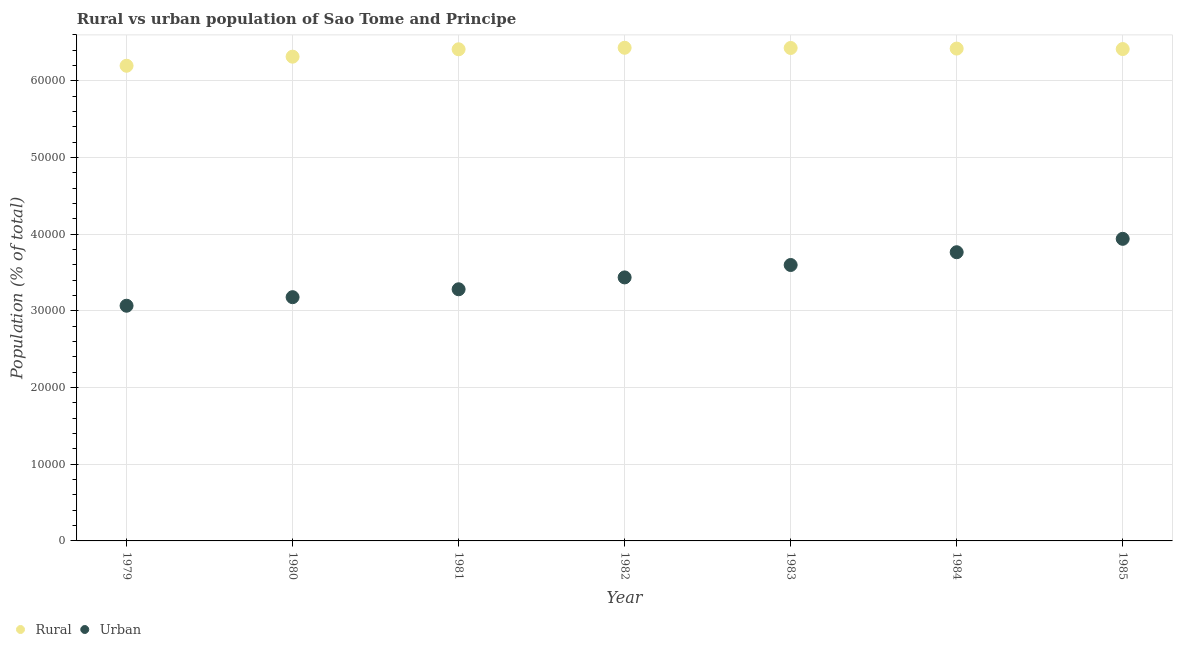Is the number of dotlines equal to the number of legend labels?
Ensure brevity in your answer.  Yes. What is the rural population density in 1984?
Ensure brevity in your answer.  6.42e+04. Across all years, what is the maximum rural population density?
Ensure brevity in your answer.  6.43e+04. Across all years, what is the minimum rural population density?
Keep it short and to the point. 6.20e+04. In which year was the urban population density maximum?
Offer a very short reply. 1985. In which year was the rural population density minimum?
Your answer should be compact. 1979. What is the total rural population density in the graph?
Your response must be concise. 4.46e+05. What is the difference between the rural population density in 1982 and that in 1985?
Keep it short and to the point. 167. What is the difference between the urban population density in 1982 and the rural population density in 1983?
Keep it short and to the point. -2.99e+04. What is the average rural population density per year?
Make the answer very short. 6.38e+04. In the year 1984, what is the difference between the urban population density and rural population density?
Keep it short and to the point. -2.66e+04. What is the ratio of the rural population density in 1982 to that in 1984?
Your answer should be very brief. 1. Is the difference between the urban population density in 1979 and 1985 greater than the difference between the rural population density in 1979 and 1985?
Provide a succinct answer. No. What is the difference between the highest and the second highest urban population density?
Offer a terse response. 1747. What is the difference between the highest and the lowest rural population density?
Give a very brief answer. 2346. Is the sum of the rural population density in 1981 and 1983 greater than the maximum urban population density across all years?
Your answer should be compact. Yes. How many dotlines are there?
Your answer should be compact. 2. What is the difference between two consecutive major ticks on the Y-axis?
Provide a short and direct response. 10000. Are the values on the major ticks of Y-axis written in scientific E-notation?
Your answer should be very brief. No. Does the graph contain any zero values?
Keep it short and to the point. No. Does the graph contain grids?
Your response must be concise. Yes. Where does the legend appear in the graph?
Provide a succinct answer. Bottom left. How many legend labels are there?
Provide a short and direct response. 2. What is the title of the graph?
Provide a short and direct response. Rural vs urban population of Sao Tome and Principe. Does "Largest city" appear as one of the legend labels in the graph?
Ensure brevity in your answer.  No. What is the label or title of the X-axis?
Your answer should be very brief. Year. What is the label or title of the Y-axis?
Provide a short and direct response. Population (% of total). What is the Population (% of total) in Rural in 1979?
Your answer should be compact. 6.20e+04. What is the Population (% of total) of Urban in 1979?
Your answer should be very brief. 3.07e+04. What is the Population (% of total) in Rural in 1980?
Provide a short and direct response. 6.32e+04. What is the Population (% of total) of Urban in 1980?
Your answer should be very brief. 3.18e+04. What is the Population (% of total) in Rural in 1981?
Provide a short and direct response. 6.41e+04. What is the Population (% of total) in Urban in 1981?
Provide a short and direct response. 3.28e+04. What is the Population (% of total) of Rural in 1982?
Your answer should be very brief. 6.43e+04. What is the Population (% of total) of Urban in 1982?
Your answer should be compact. 3.44e+04. What is the Population (% of total) in Rural in 1983?
Offer a terse response. 6.43e+04. What is the Population (% of total) in Urban in 1983?
Offer a very short reply. 3.60e+04. What is the Population (% of total) in Rural in 1984?
Keep it short and to the point. 6.42e+04. What is the Population (% of total) in Urban in 1984?
Offer a terse response. 3.77e+04. What is the Population (% of total) of Rural in 1985?
Your answer should be compact. 6.42e+04. What is the Population (% of total) of Urban in 1985?
Your response must be concise. 3.94e+04. Across all years, what is the maximum Population (% of total) in Rural?
Provide a succinct answer. 6.43e+04. Across all years, what is the maximum Population (% of total) in Urban?
Offer a very short reply. 3.94e+04. Across all years, what is the minimum Population (% of total) in Rural?
Your answer should be very brief. 6.20e+04. Across all years, what is the minimum Population (% of total) in Urban?
Keep it short and to the point. 3.07e+04. What is the total Population (% of total) in Rural in the graph?
Your response must be concise. 4.46e+05. What is the total Population (% of total) of Urban in the graph?
Your answer should be very brief. 2.43e+05. What is the difference between the Population (% of total) in Rural in 1979 and that in 1980?
Provide a short and direct response. -1185. What is the difference between the Population (% of total) in Urban in 1979 and that in 1980?
Your response must be concise. -1116. What is the difference between the Population (% of total) in Rural in 1979 and that in 1981?
Make the answer very short. -2148. What is the difference between the Population (% of total) in Urban in 1979 and that in 1981?
Give a very brief answer. -2147. What is the difference between the Population (% of total) in Rural in 1979 and that in 1982?
Make the answer very short. -2346. What is the difference between the Population (% of total) of Urban in 1979 and that in 1982?
Your response must be concise. -3694. What is the difference between the Population (% of total) of Rural in 1979 and that in 1983?
Offer a very short reply. -2320. What is the difference between the Population (% of total) in Urban in 1979 and that in 1983?
Offer a terse response. -5313. What is the difference between the Population (% of total) in Rural in 1979 and that in 1984?
Provide a short and direct response. -2240. What is the difference between the Population (% of total) of Urban in 1979 and that in 1984?
Provide a succinct answer. -6979. What is the difference between the Population (% of total) in Rural in 1979 and that in 1985?
Offer a terse response. -2179. What is the difference between the Population (% of total) of Urban in 1979 and that in 1985?
Offer a very short reply. -8726. What is the difference between the Population (% of total) of Rural in 1980 and that in 1981?
Provide a short and direct response. -963. What is the difference between the Population (% of total) in Urban in 1980 and that in 1981?
Offer a very short reply. -1031. What is the difference between the Population (% of total) in Rural in 1980 and that in 1982?
Make the answer very short. -1161. What is the difference between the Population (% of total) of Urban in 1980 and that in 1982?
Ensure brevity in your answer.  -2578. What is the difference between the Population (% of total) of Rural in 1980 and that in 1983?
Keep it short and to the point. -1135. What is the difference between the Population (% of total) in Urban in 1980 and that in 1983?
Provide a succinct answer. -4197. What is the difference between the Population (% of total) of Rural in 1980 and that in 1984?
Ensure brevity in your answer.  -1055. What is the difference between the Population (% of total) in Urban in 1980 and that in 1984?
Give a very brief answer. -5863. What is the difference between the Population (% of total) of Rural in 1980 and that in 1985?
Keep it short and to the point. -994. What is the difference between the Population (% of total) of Urban in 1980 and that in 1985?
Provide a short and direct response. -7610. What is the difference between the Population (% of total) of Rural in 1981 and that in 1982?
Provide a succinct answer. -198. What is the difference between the Population (% of total) in Urban in 1981 and that in 1982?
Give a very brief answer. -1547. What is the difference between the Population (% of total) of Rural in 1981 and that in 1983?
Your answer should be compact. -172. What is the difference between the Population (% of total) in Urban in 1981 and that in 1983?
Your answer should be compact. -3166. What is the difference between the Population (% of total) in Rural in 1981 and that in 1984?
Offer a very short reply. -92. What is the difference between the Population (% of total) in Urban in 1981 and that in 1984?
Provide a short and direct response. -4832. What is the difference between the Population (% of total) in Rural in 1981 and that in 1985?
Offer a very short reply. -31. What is the difference between the Population (% of total) in Urban in 1981 and that in 1985?
Give a very brief answer. -6579. What is the difference between the Population (% of total) in Urban in 1982 and that in 1983?
Offer a terse response. -1619. What is the difference between the Population (% of total) in Rural in 1982 and that in 1984?
Your response must be concise. 106. What is the difference between the Population (% of total) in Urban in 1982 and that in 1984?
Your answer should be compact. -3285. What is the difference between the Population (% of total) in Rural in 1982 and that in 1985?
Provide a short and direct response. 167. What is the difference between the Population (% of total) in Urban in 1982 and that in 1985?
Ensure brevity in your answer.  -5032. What is the difference between the Population (% of total) in Rural in 1983 and that in 1984?
Your answer should be compact. 80. What is the difference between the Population (% of total) in Urban in 1983 and that in 1984?
Provide a succinct answer. -1666. What is the difference between the Population (% of total) of Rural in 1983 and that in 1985?
Offer a very short reply. 141. What is the difference between the Population (% of total) in Urban in 1983 and that in 1985?
Provide a short and direct response. -3413. What is the difference between the Population (% of total) in Rural in 1984 and that in 1985?
Make the answer very short. 61. What is the difference between the Population (% of total) in Urban in 1984 and that in 1985?
Ensure brevity in your answer.  -1747. What is the difference between the Population (% of total) of Rural in 1979 and the Population (% of total) of Urban in 1980?
Offer a terse response. 3.02e+04. What is the difference between the Population (% of total) in Rural in 1979 and the Population (% of total) in Urban in 1981?
Provide a succinct answer. 2.92e+04. What is the difference between the Population (% of total) in Rural in 1979 and the Population (% of total) in Urban in 1982?
Provide a succinct answer. 2.76e+04. What is the difference between the Population (% of total) of Rural in 1979 and the Population (% of total) of Urban in 1983?
Make the answer very short. 2.60e+04. What is the difference between the Population (% of total) in Rural in 1979 and the Population (% of total) in Urban in 1984?
Give a very brief answer. 2.43e+04. What is the difference between the Population (% of total) of Rural in 1979 and the Population (% of total) of Urban in 1985?
Provide a short and direct response. 2.26e+04. What is the difference between the Population (% of total) in Rural in 1980 and the Population (% of total) in Urban in 1981?
Provide a succinct answer. 3.03e+04. What is the difference between the Population (% of total) of Rural in 1980 and the Population (% of total) of Urban in 1982?
Ensure brevity in your answer.  2.88e+04. What is the difference between the Population (% of total) in Rural in 1980 and the Population (% of total) in Urban in 1983?
Offer a very short reply. 2.72e+04. What is the difference between the Population (% of total) in Rural in 1980 and the Population (% of total) in Urban in 1984?
Your answer should be compact. 2.55e+04. What is the difference between the Population (% of total) of Rural in 1980 and the Population (% of total) of Urban in 1985?
Offer a terse response. 2.38e+04. What is the difference between the Population (% of total) in Rural in 1981 and the Population (% of total) in Urban in 1982?
Give a very brief answer. 2.98e+04. What is the difference between the Population (% of total) in Rural in 1981 and the Population (% of total) in Urban in 1983?
Give a very brief answer. 2.81e+04. What is the difference between the Population (% of total) of Rural in 1981 and the Population (% of total) of Urban in 1984?
Your answer should be compact. 2.65e+04. What is the difference between the Population (% of total) of Rural in 1981 and the Population (% of total) of Urban in 1985?
Make the answer very short. 2.47e+04. What is the difference between the Population (% of total) in Rural in 1982 and the Population (% of total) in Urban in 1983?
Offer a very short reply. 2.83e+04. What is the difference between the Population (% of total) in Rural in 1982 and the Population (% of total) in Urban in 1984?
Offer a very short reply. 2.67e+04. What is the difference between the Population (% of total) of Rural in 1982 and the Population (% of total) of Urban in 1985?
Your response must be concise. 2.49e+04. What is the difference between the Population (% of total) in Rural in 1983 and the Population (% of total) in Urban in 1984?
Ensure brevity in your answer.  2.66e+04. What is the difference between the Population (% of total) in Rural in 1983 and the Population (% of total) in Urban in 1985?
Your response must be concise. 2.49e+04. What is the difference between the Population (% of total) of Rural in 1984 and the Population (% of total) of Urban in 1985?
Ensure brevity in your answer.  2.48e+04. What is the average Population (% of total) of Rural per year?
Your answer should be compact. 6.38e+04. What is the average Population (% of total) of Urban per year?
Your answer should be compact. 3.47e+04. In the year 1979, what is the difference between the Population (% of total) in Rural and Population (% of total) in Urban?
Provide a short and direct response. 3.13e+04. In the year 1980, what is the difference between the Population (% of total) in Rural and Population (% of total) in Urban?
Your response must be concise. 3.14e+04. In the year 1981, what is the difference between the Population (% of total) of Rural and Population (% of total) of Urban?
Provide a succinct answer. 3.13e+04. In the year 1982, what is the difference between the Population (% of total) of Rural and Population (% of total) of Urban?
Provide a succinct answer. 3.00e+04. In the year 1983, what is the difference between the Population (% of total) of Rural and Population (% of total) of Urban?
Keep it short and to the point. 2.83e+04. In the year 1984, what is the difference between the Population (% of total) of Rural and Population (% of total) of Urban?
Your response must be concise. 2.66e+04. In the year 1985, what is the difference between the Population (% of total) in Rural and Population (% of total) in Urban?
Offer a very short reply. 2.48e+04. What is the ratio of the Population (% of total) of Rural in 1979 to that in 1980?
Ensure brevity in your answer.  0.98. What is the ratio of the Population (% of total) in Urban in 1979 to that in 1980?
Offer a terse response. 0.96. What is the ratio of the Population (% of total) of Rural in 1979 to that in 1981?
Your answer should be very brief. 0.97. What is the ratio of the Population (% of total) in Urban in 1979 to that in 1981?
Offer a very short reply. 0.93. What is the ratio of the Population (% of total) in Rural in 1979 to that in 1982?
Your response must be concise. 0.96. What is the ratio of the Population (% of total) in Urban in 1979 to that in 1982?
Your answer should be very brief. 0.89. What is the ratio of the Population (% of total) in Rural in 1979 to that in 1983?
Keep it short and to the point. 0.96. What is the ratio of the Population (% of total) of Urban in 1979 to that in 1983?
Provide a short and direct response. 0.85. What is the ratio of the Population (% of total) of Rural in 1979 to that in 1984?
Offer a terse response. 0.97. What is the ratio of the Population (% of total) of Urban in 1979 to that in 1984?
Your response must be concise. 0.81. What is the ratio of the Population (% of total) of Urban in 1979 to that in 1985?
Your answer should be compact. 0.78. What is the ratio of the Population (% of total) in Rural in 1980 to that in 1981?
Give a very brief answer. 0.98. What is the ratio of the Population (% of total) of Urban in 1980 to that in 1981?
Your answer should be very brief. 0.97. What is the ratio of the Population (% of total) in Urban in 1980 to that in 1982?
Your answer should be very brief. 0.93. What is the ratio of the Population (% of total) of Rural in 1980 to that in 1983?
Your response must be concise. 0.98. What is the ratio of the Population (% of total) of Urban in 1980 to that in 1983?
Your answer should be compact. 0.88. What is the ratio of the Population (% of total) of Rural in 1980 to that in 1984?
Give a very brief answer. 0.98. What is the ratio of the Population (% of total) in Urban in 1980 to that in 1984?
Make the answer very short. 0.84. What is the ratio of the Population (% of total) of Rural in 1980 to that in 1985?
Your answer should be compact. 0.98. What is the ratio of the Population (% of total) in Urban in 1980 to that in 1985?
Provide a short and direct response. 0.81. What is the ratio of the Population (% of total) of Rural in 1981 to that in 1982?
Provide a succinct answer. 1. What is the ratio of the Population (% of total) of Urban in 1981 to that in 1982?
Offer a very short reply. 0.95. What is the ratio of the Population (% of total) of Urban in 1981 to that in 1983?
Ensure brevity in your answer.  0.91. What is the ratio of the Population (% of total) in Rural in 1981 to that in 1984?
Provide a short and direct response. 1. What is the ratio of the Population (% of total) in Urban in 1981 to that in 1984?
Ensure brevity in your answer.  0.87. What is the ratio of the Population (% of total) in Urban in 1981 to that in 1985?
Provide a succinct answer. 0.83. What is the ratio of the Population (% of total) of Urban in 1982 to that in 1983?
Offer a terse response. 0.95. What is the ratio of the Population (% of total) of Rural in 1982 to that in 1984?
Keep it short and to the point. 1. What is the ratio of the Population (% of total) of Urban in 1982 to that in 1984?
Provide a short and direct response. 0.91. What is the ratio of the Population (% of total) in Urban in 1982 to that in 1985?
Provide a succinct answer. 0.87. What is the ratio of the Population (% of total) of Rural in 1983 to that in 1984?
Ensure brevity in your answer.  1. What is the ratio of the Population (% of total) of Urban in 1983 to that in 1984?
Keep it short and to the point. 0.96. What is the ratio of the Population (% of total) of Rural in 1983 to that in 1985?
Keep it short and to the point. 1. What is the ratio of the Population (% of total) of Urban in 1983 to that in 1985?
Keep it short and to the point. 0.91. What is the ratio of the Population (% of total) in Urban in 1984 to that in 1985?
Your response must be concise. 0.96. What is the difference between the highest and the second highest Population (% of total) of Rural?
Offer a very short reply. 26. What is the difference between the highest and the second highest Population (% of total) in Urban?
Give a very brief answer. 1747. What is the difference between the highest and the lowest Population (% of total) in Rural?
Offer a terse response. 2346. What is the difference between the highest and the lowest Population (% of total) in Urban?
Offer a very short reply. 8726. 